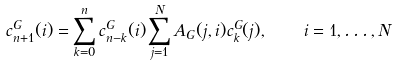Convert formula to latex. <formula><loc_0><loc_0><loc_500><loc_500>c _ { n + 1 } ^ { G } ( i ) = \sum _ { k = 0 } ^ { n } c _ { n - k } ^ { G } ( i ) \sum _ { j = 1 } ^ { N } A _ { G } ( j , i ) c _ { k } ^ { G } ( j ) , \quad i = 1 , \dots , N</formula> 